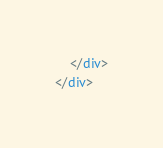<code> <loc_0><loc_0><loc_500><loc_500><_HTML_>    </div>
</div></code> 